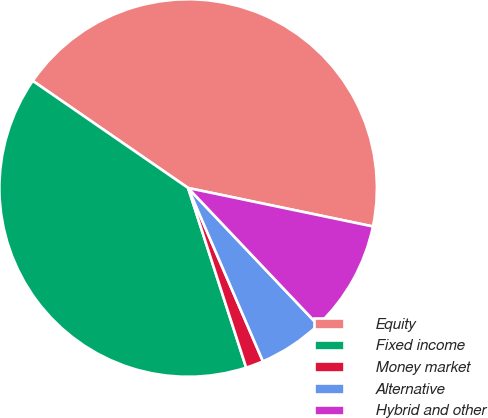<chart> <loc_0><loc_0><loc_500><loc_500><pie_chart><fcel>Equity<fcel>Fixed income<fcel>Money market<fcel>Alternative<fcel>Hybrid and other<nl><fcel>43.66%<fcel>39.58%<fcel>1.51%<fcel>5.59%<fcel>9.66%<nl></chart> 